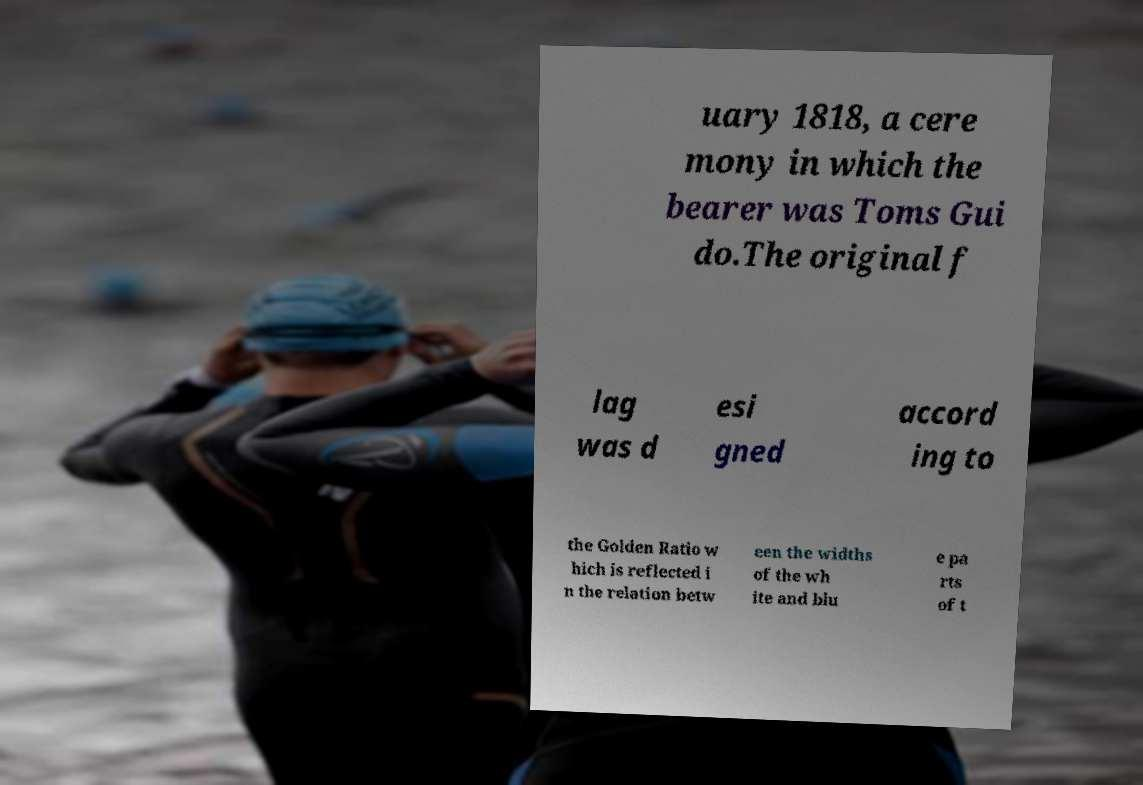For documentation purposes, I need the text within this image transcribed. Could you provide that? uary 1818, a cere mony in which the bearer was Toms Gui do.The original f lag was d esi gned accord ing to the Golden Ratio w hich is reflected i n the relation betw een the widths of the wh ite and blu e pa rts of t 